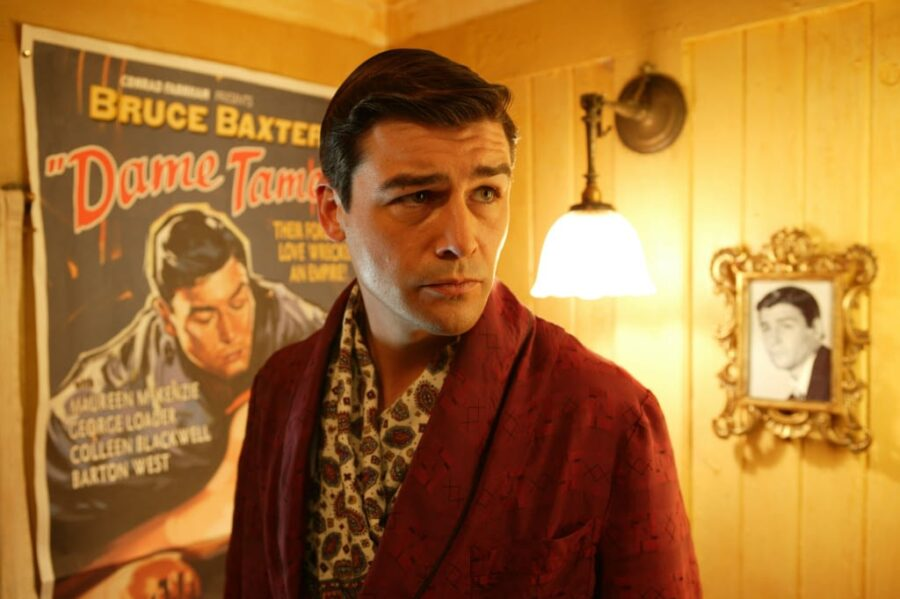What details in the image suggest it might be a promotional event for a movie? The presence of a large movie poster in the background, prominently featuring a dramatic illustration and the presence of the actor dressed in thematic attire, strongly suggests a promotional event for a movie. The setting itself, decorated with elements that accentuate the theme, supports the idea of a staged promotional setting aimed at creating a specific ambiance. What elements in the room match the actor’s attire? The actor’s robe, which features a rich, floral pattern and bold red color, complements the vintage and luxurious feel of the room. Elements like the golden frame on the wall and the intricate chandelier resonate with the robe's decorative style, thereby harmonizing his attire with the room's classical and ornate aesthetics. 